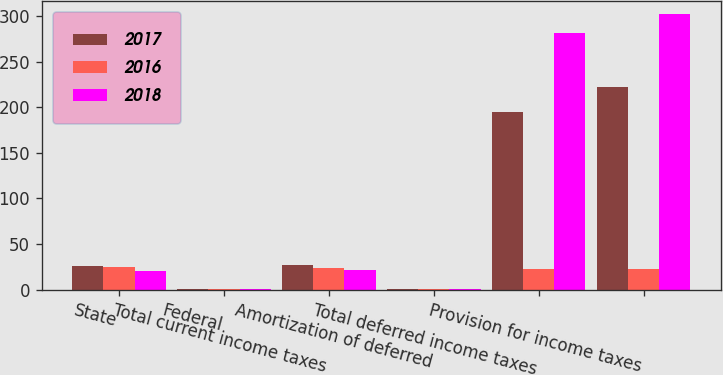Convert chart to OTSL. <chart><loc_0><loc_0><loc_500><loc_500><stacked_bar_chart><ecel><fcel>State<fcel>Federal<fcel>Total current income taxes<fcel>Amortization of deferred<fcel>Total deferred income taxes<fcel>Provision for income taxes<nl><fcel>2017<fcel>26<fcel>1<fcel>27<fcel>1<fcel>195<fcel>222<nl><fcel>2016<fcel>25<fcel>1<fcel>24<fcel>1<fcel>22.5<fcel>22.5<nl><fcel>2018<fcel>20<fcel>1<fcel>21<fcel>1<fcel>281<fcel>302<nl></chart> 